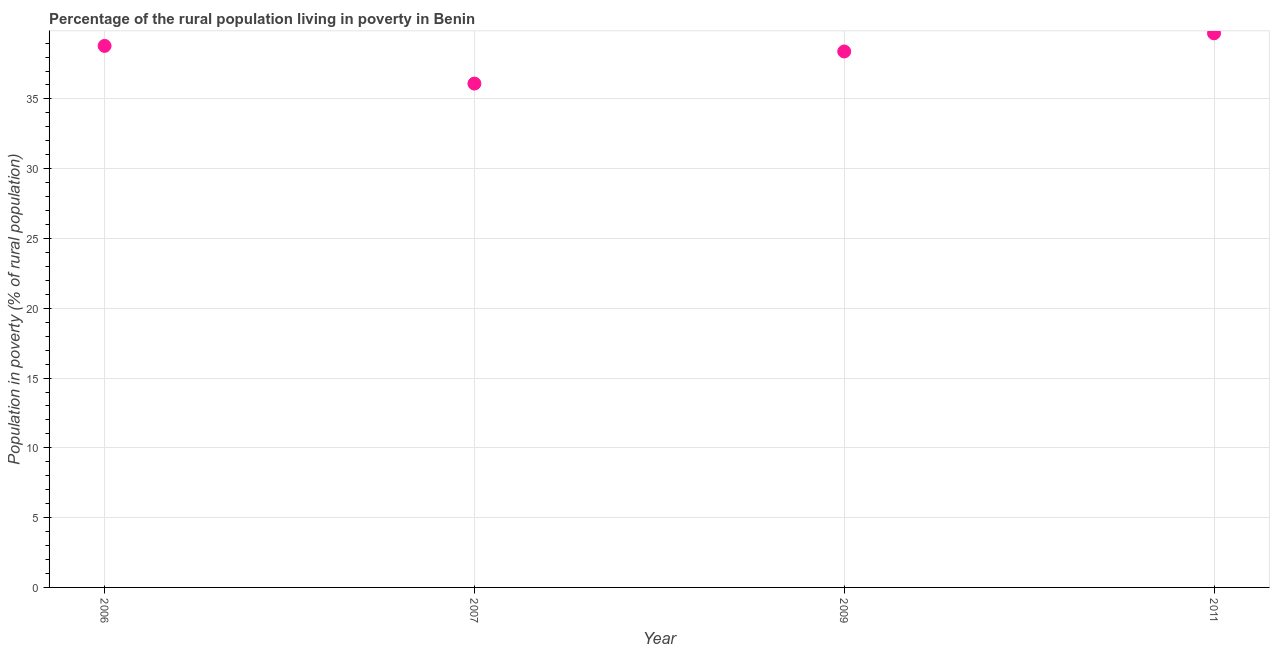What is the percentage of rural population living below poverty line in 2009?
Your response must be concise. 38.4. Across all years, what is the maximum percentage of rural population living below poverty line?
Provide a succinct answer. 39.7. Across all years, what is the minimum percentage of rural population living below poverty line?
Keep it short and to the point. 36.1. What is the sum of the percentage of rural population living below poverty line?
Give a very brief answer. 153. What is the difference between the percentage of rural population living below poverty line in 2006 and 2007?
Offer a very short reply. 2.7. What is the average percentage of rural population living below poverty line per year?
Give a very brief answer. 38.25. What is the median percentage of rural population living below poverty line?
Ensure brevity in your answer.  38.6. Do a majority of the years between 2011 and 2007 (inclusive) have percentage of rural population living below poverty line greater than 1 %?
Your response must be concise. No. What is the ratio of the percentage of rural population living below poverty line in 2007 to that in 2011?
Give a very brief answer. 0.91. What is the difference between the highest and the second highest percentage of rural population living below poverty line?
Ensure brevity in your answer.  0.9. What is the difference between the highest and the lowest percentage of rural population living below poverty line?
Offer a terse response. 3.6. In how many years, is the percentage of rural population living below poverty line greater than the average percentage of rural population living below poverty line taken over all years?
Offer a very short reply. 3. Does the percentage of rural population living below poverty line monotonically increase over the years?
Your answer should be very brief. No. What is the difference between two consecutive major ticks on the Y-axis?
Keep it short and to the point. 5. Are the values on the major ticks of Y-axis written in scientific E-notation?
Make the answer very short. No. Does the graph contain any zero values?
Keep it short and to the point. No. Does the graph contain grids?
Make the answer very short. Yes. What is the title of the graph?
Keep it short and to the point. Percentage of the rural population living in poverty in Benin. What is the label or title of the Y-axis?
Give a very brief answer. Population in poverty (% of rural population). What is the Population in poverty (% of rural population) in 2006?
Your response must be concise. 38.8. What is the Population in poverty (% of rural population) in 2007?
Provide a succinct answer. 36.1. What is the Population in poverty (% of rural population) in 2009?
Your answer should be compact. 38.4. What is the Population in poverty (% of rural population) in 2011?
Your response must be concise. 39.7. What is the difference between the Population in poverty (% of rural population) in 2006 and 2011?
Your response must be concise. -0.9. What is the difference between the Population in poverty (% of rural population) in 2007 and 2009?
Ensure brevity in your answer.  -2.3. What is the difference between the Population in poverty (% of rural population) in 2009 and 2011?
Make the answer very short. -1.3. What is the ratio of the Population in poverty (% of rural population) in 2006 to that in 2007?
Make the answer very short. 1.07. What is the ratio of the Population in poverty (% of rural population) in 2006 to that in 2009?
Provide a succinct answer. 1.01. What is the ratio of the Population in poverty (% of rural population) in 2006 to that in 2011?
Provide a short and direct response. 0.98. What is the ratio of the Population in poverty (% of rural population) in 2007 to that in 2009?
Give a very brief answer. 0.94. What is the ratio of the Population in poverty (% of rural population) in 2007 to that in 2011?
Ensure brevity in your answer.  0.91. What is the ratio of the Population in poverty (% of rural population) in 2009 to that in 2011?
Offer a very short reply. 0.97. 